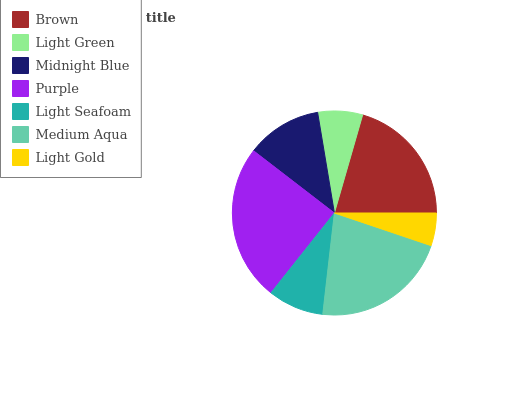Is Light Gold the minimum?
Answer yes or no. Yes. Is Purple the maximum?
Answer yes or no. Yes. Is Light Green the minimum?
Answer yes or no. No. Is Light Green the maximum?
Answer yes or no. No. Is Brown greater than Light Green?
Answer yes or no. Yes. Is Light Green less than Brown?
Answer yes or no. Yes. Is Light Green greater than Brown?
Answer yes or no. No. Is Brown less than Light Green?
Answer yes or no. No. Is Midnight Blue the high median?
Answer yes or no. Yes. Is Midnight Blue the low median?
Answer yes or no. Yes. Is Purple the high median?
Answer yes or no. No. Is Light Green the low median?
Answer yes or no. No. 